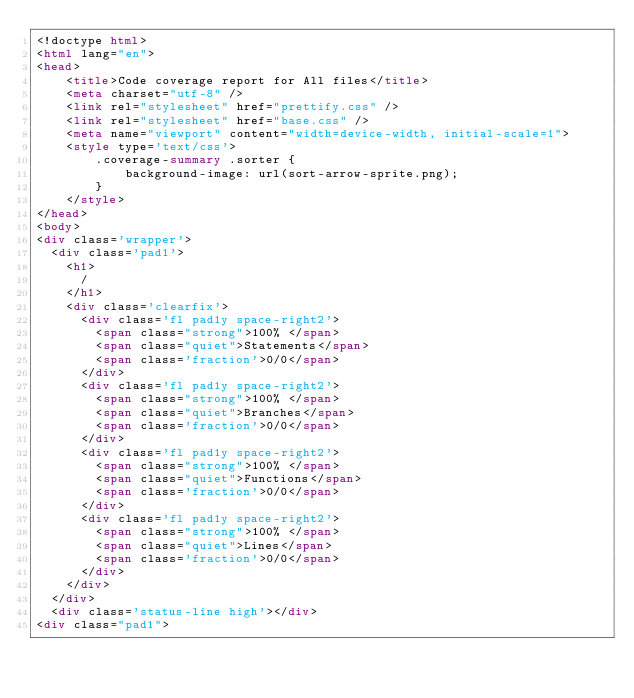Convert code to text. <code><loc_0><loc_0><loc_500><loc_500><_HTML_><!doctype html>
<html lang="en">
<head>
    <title>Code coverage report for All files</title>
    <meta charset="utf-8" />
    <link rel="stylesheet" href="prettify.css" />
    <link rel="stylesheet" href="base.css" />
    <meta name="viewport" content="width=device-width, initial-scale=1">
    <style type='text/css'>
        .coverage-summary .sorter {
            background-image: url(sort-arrow-sprite.png);
        }
    </style>
</head>
<body>
<div class='wrapper'>
  <div class='pad1'>
    <h1>
      /
    </h1>
    <div class='clearfix'>
      <div class='fl pad1y space-right2'>
        <span class="strong">100% </span>
        <span class="quiet">Statements</span>
        <span class='fraction'>0/0</span>
      </div>
      <div class='fl pad1y space-right2'>
        <span class="strong">100% </span>
        <span class="quiet">Branches</span>
        <span class='fraction'>0/0</span>
      </div>
      <div class='fl pad1y space-right2'>
        <span class="strong">100% </span>
        <span class="quiet">Functions</span>
        <span class='fraction'>0/0</span>
      </div>
      <div class='fl pad1y space-right2'>
        <span class="strong">100% </span>
        <span class="quiet">Lines</span>
        <span class='fraction'>0/0</span>
      </div>
    </div>
  </div>
  <div class='status-line high'></div>
<div class="pad1"></code> 